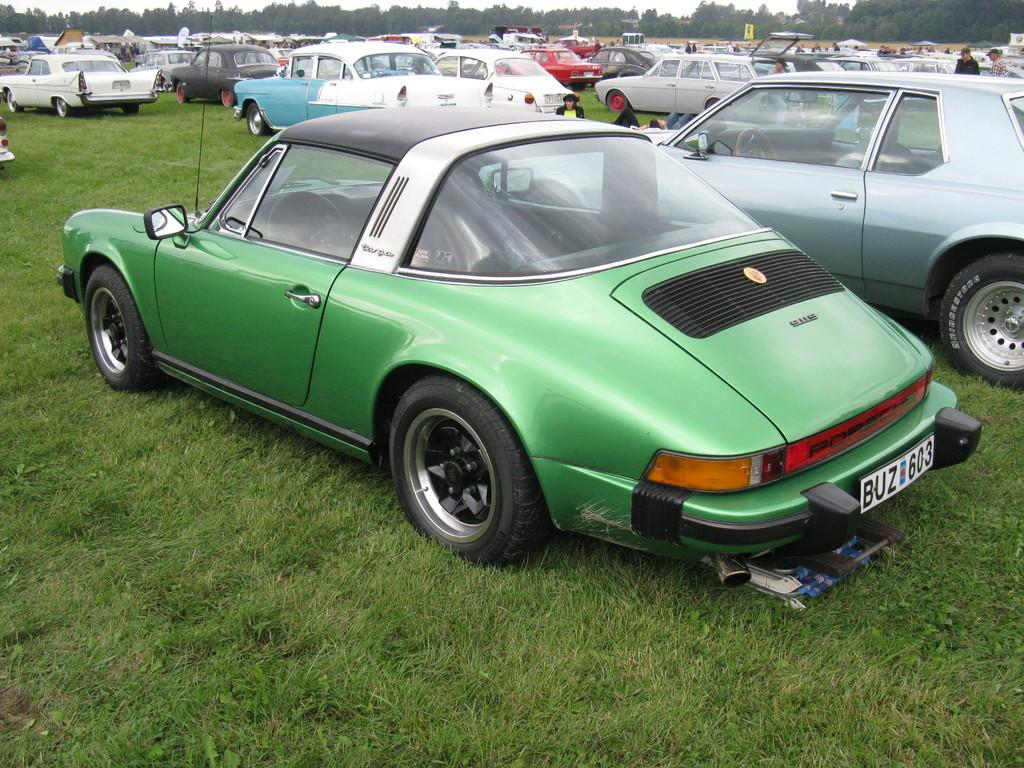What type of vehicles can be seen in the image? There are cars in the image. What are the people in the image doing? The people in the image are standing on the ground. What can be seen in the background of the image? There are trees and the sky visible in the background of the image. What type of vegetation is present in the image? There is grass in the image. Can you see a quill being used to write on a glass in the image? There is no quill or glass present in the image, and therefore no such activity can be observed. What type of pickle is being held by the person in the image? There is no pickle present in the image; the people are standing on the ground without any visible objects in their hands. 